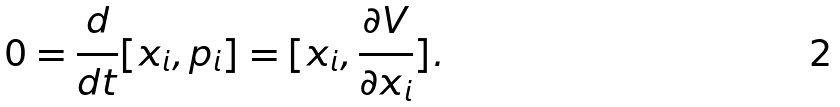Convert formula to latex. <formula><loc_0><loc_0><loc_500><loc_500>0 = \frac { d } { d t } [ x _ { i } , p _ { i } ] = [ x _ { i } , \frac { \partial V } { \partial x _ { i } } ] .</formula> 